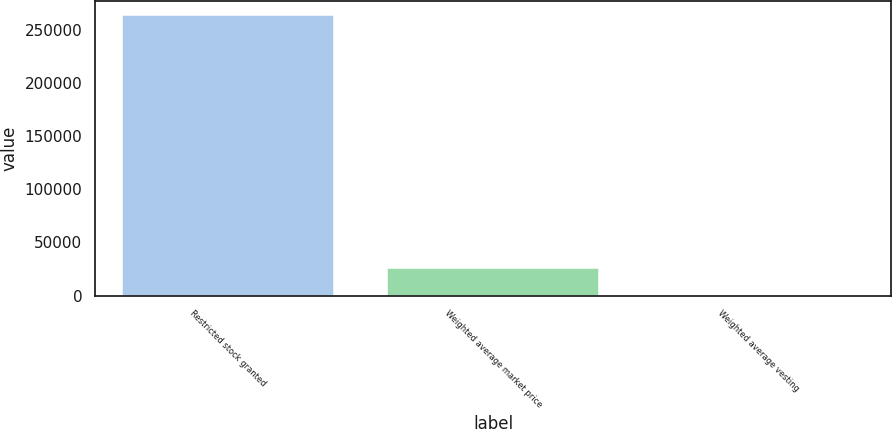Convert chart to OTSL. <chart><loc_0><loc_0><loc_500><loc_500><bar_chart><fcel>Restricted stock granted<fcel>Weighted average market price<fcel>Weighted average vesting<nl><fcel>263771<fcel>26379.9<fcel>3.09<nl></chart> 